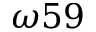<formula> <loc_0><loc_0><loc_500><loc_500>\omega 5 9</formula> 